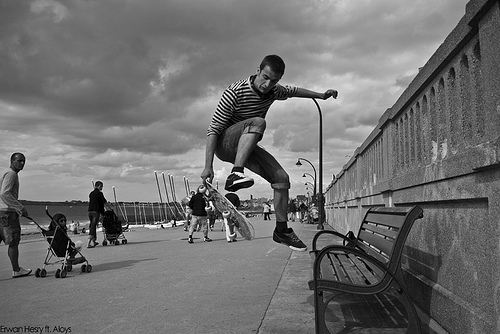Please transcribe the text in this image. ALOYS 